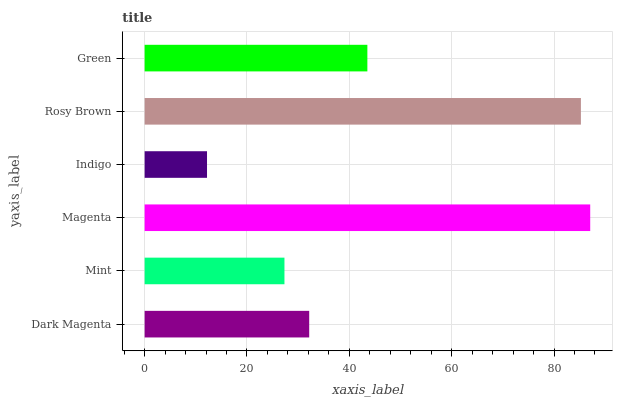Is Indigo the minimum?
Answer yes or no. Yes. Is Magenta the maximum?
Answer yes or no. Yes. Is Mint the minimum?
Answer yes or no. No. Is Mint the maximum?
Answer yes or no. No. Is Dark Magenta greater than Mint?
Answer yes or no. Yes. Is Mint less than Dark Magenta?
Answer yes or no. Yes. Is Mint greater than Dark Magenta?
Answer yes or no. No. Is Dark Magenta less than Mint?
Answer yes or no. No. Is Green the high median?
Answer yes or no. Yes. Is Dark Magenta the low median?
Answer yes or no. Yes. Is Magenta the high median?
Answer yes or no. No. Is Green the low median?
Answer yes or no. No. 